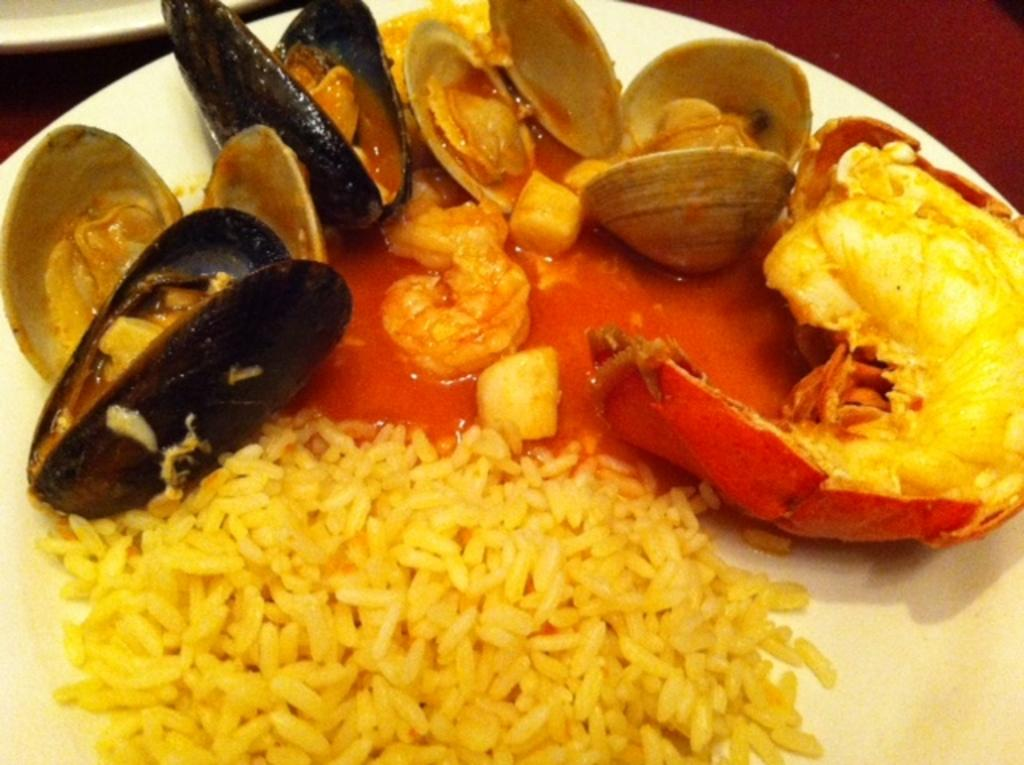What is the main object in the center of the image? There is a plate in the center of the image. What is on the plate? The plate contains food items. How many fathers are present in the image? There is no reference to a father or any people in the image, so it is not possible to determine the number of fathers present. 